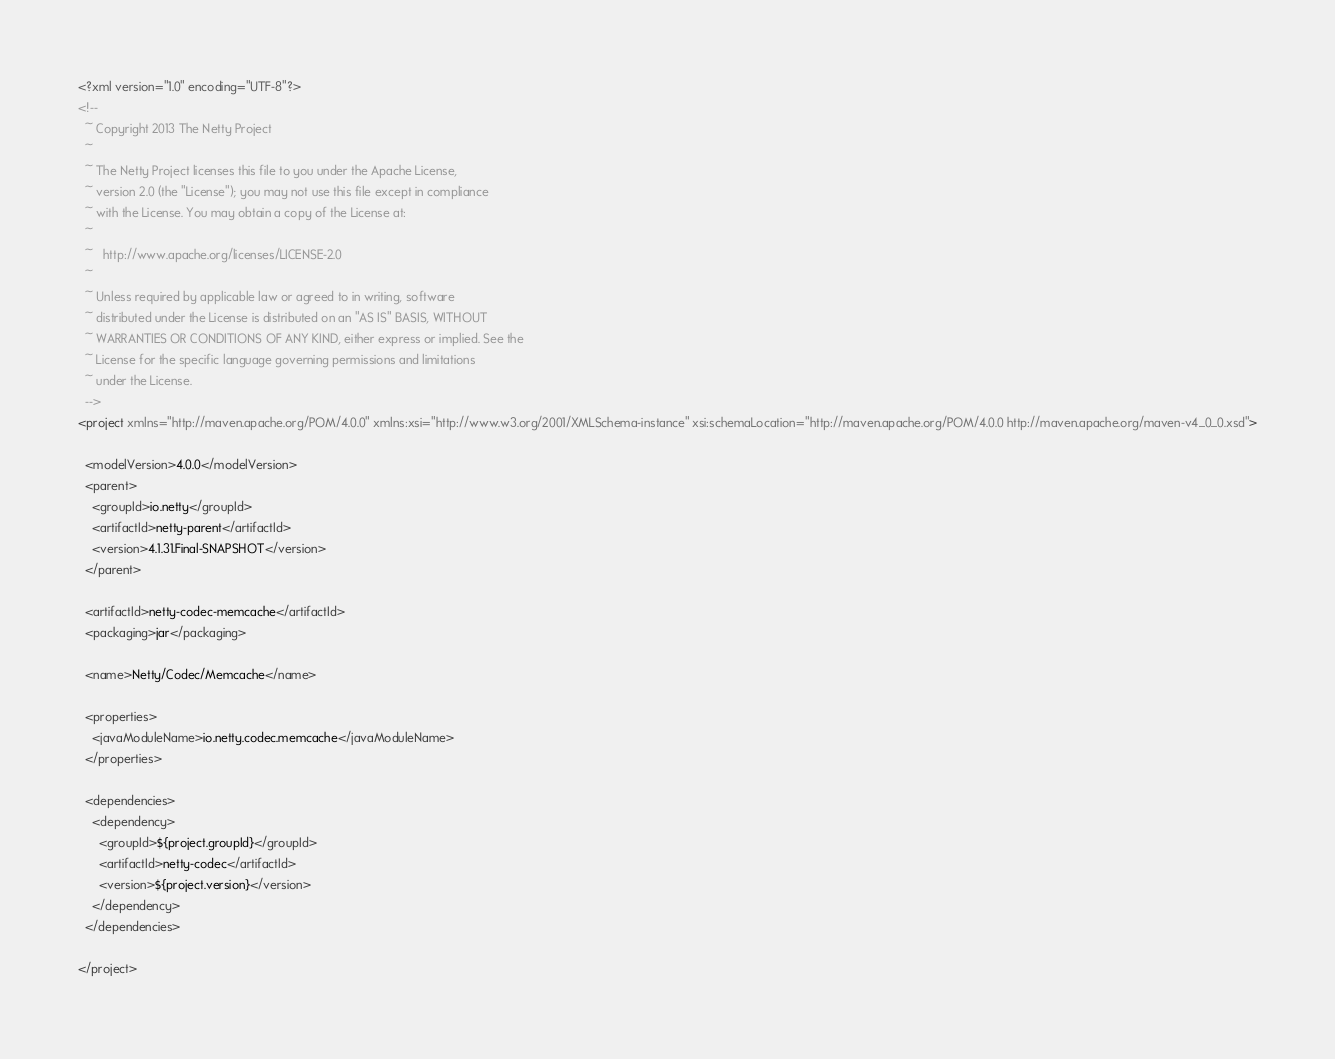Convert code to text. <code><loc_0><loc_0><loc_500><loc_500><_XML_><?xml version="1.0" encoding="UTF-8"?>
<!--
  ~ Copyright 2013 The Netty Project
  ~
  ~ The Netty Project licenses this file to you under the Apache License,
  ~ version 2.0 (the "License"); you may not use this file except in compliance
  ~ with the License. You may obtain a copy of the License at:
  ~
  ~   http://www.apache.org/licenses/LICENSE-2.0
  ~
  ~ Unless required by applicable law or agreed to in writing, software
  ~ distributed under the License is distributed on an "AS IS" BASIS, WITHOUT
  ~ WARRANTIES OR CONDITIONS OF ANY KIND, either express or implied. See the
  ~ License for the specific language governing permissions and limitations
  ~ under the License.
  -->
<project xmlns="http://maven.apache.org/POM/4.0.0" xmlns:xsi="http://www.w3.org/2001/XMLSchema-instance" xsi:schemaLocation="http://maven.apache.org/POM/4.0.0 http://maven.apache.org/maven-v4_0_0.xsd">

  <modelVersion>4.0.0</modelVersion>
  <parent>
    <groupId>io.netty</groupId>
    <artifactId>netty-parent</artifactId>
    <version>4.1.31.Final-SNAPSHOT</version>
  </parent>

  <artifactId>netty-codec-memcache</artifactId>
  <packaging>jar</packaging>

  <name>Netty/Codec/Memcache</name>

  <properties>
    <javaModuleName>io.netty.codec.memcache</javaModuleName>
  </properties>

  <dependencies>
    <dependency>
      <groupId>${project.groupId}</groupId>
      <artifactId>netty-codec</artifactId>
      <version>${project.version}</version>
    </dependency>
  </dependencies>

</project>

</code> 